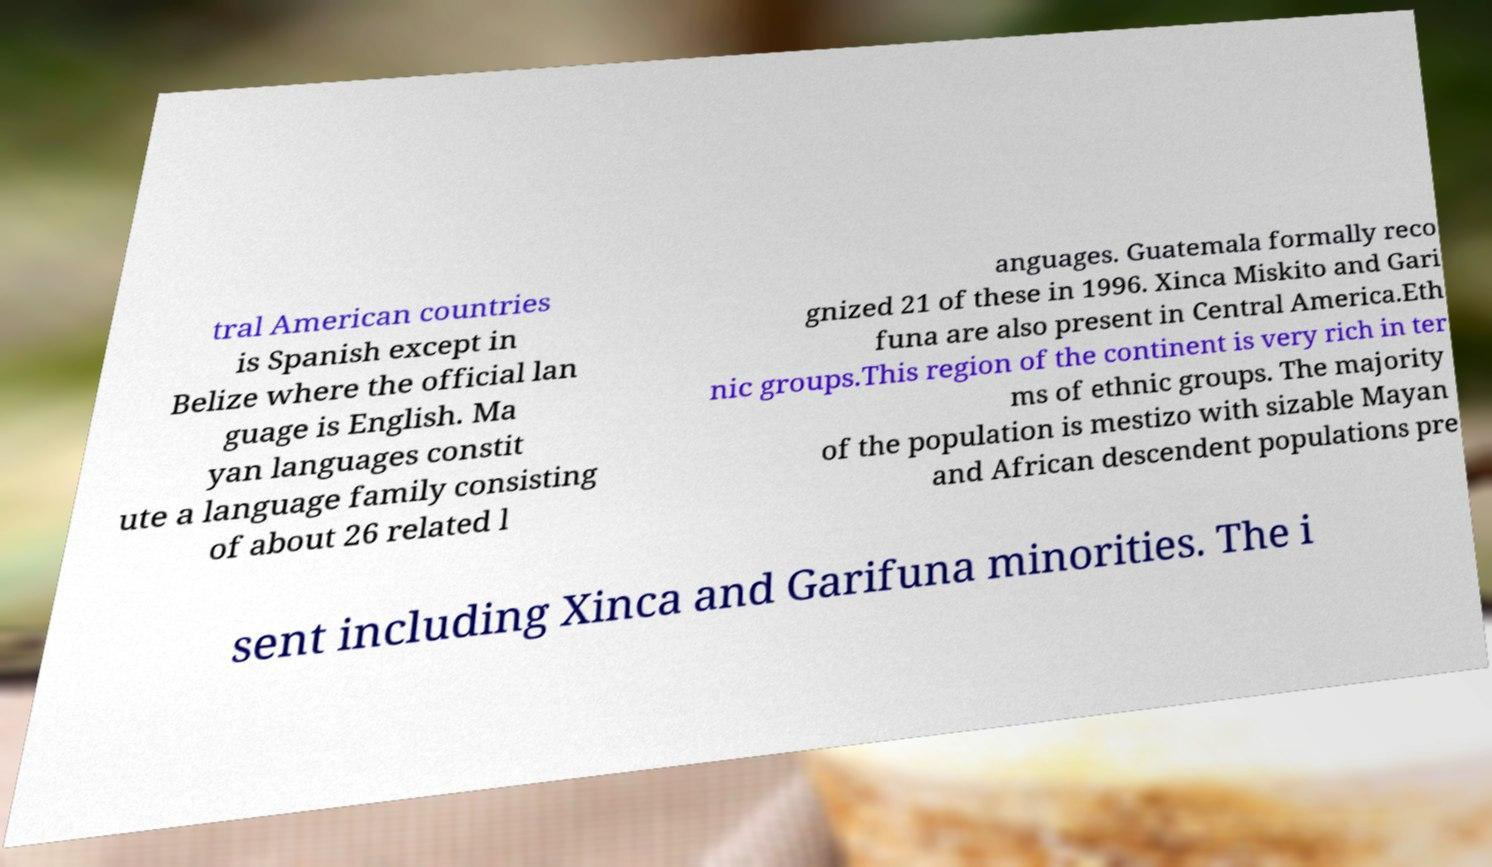Could you assist in decoding the text presented in this image and type it out clearly? tral American countries is Spanish except in Belize where the official lan guage is English. Ma yan languages constit ute a language family consisting of about 26 related l anguages. Guatemala formally reco gnized 21 of these in 1996. Xinca Miskito and Gari funa are also present in Central America.Eth nic groups.This region of the continent is very rich in ter ms of ethnic groups. The majority of the population is mestizo with sizable Mayan and African descendent populations pre sent including Xinca and Garifuna minorities. The i 